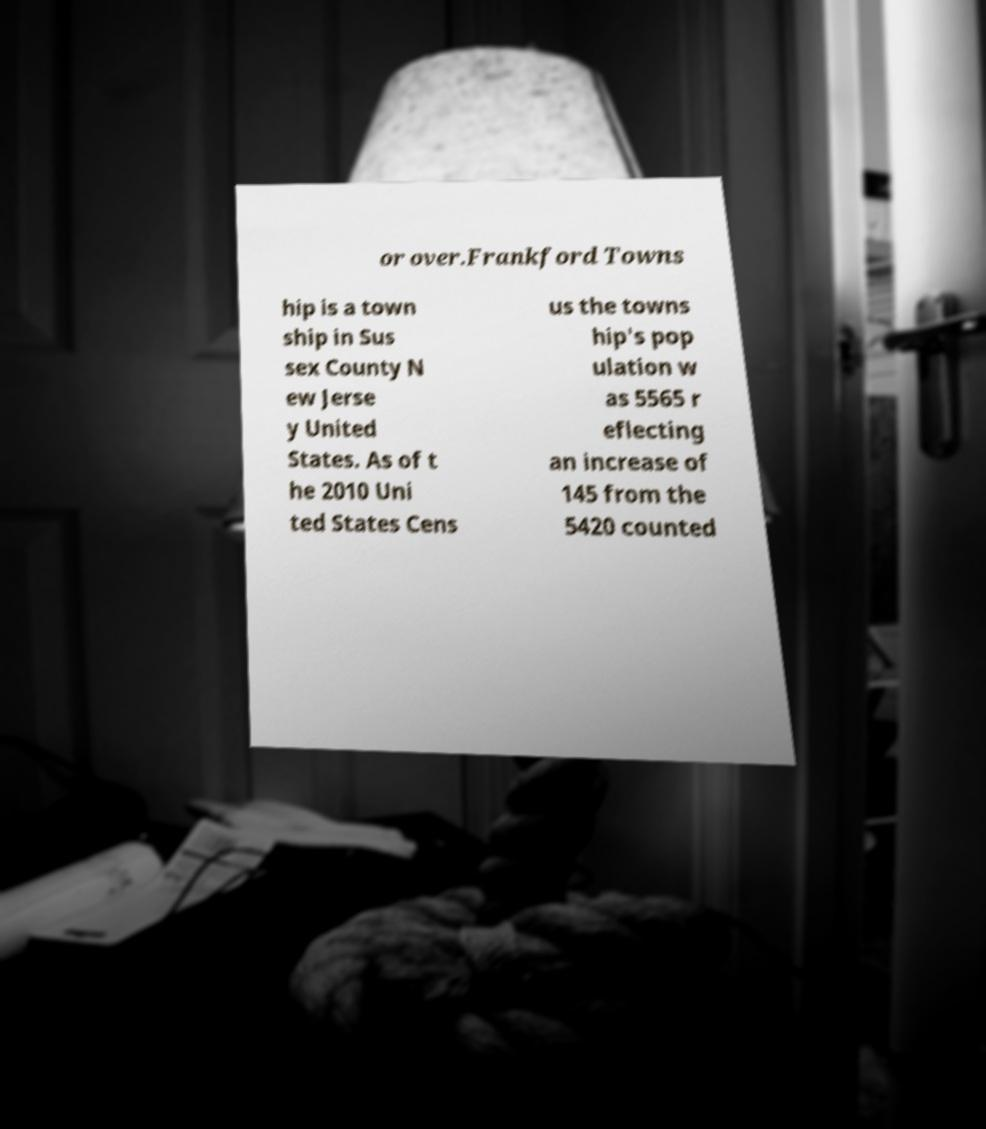For documentation purposes, I need the text within this image transcribed. Could you provide that? or over.Frankford Towns hip is a town ship in Sus sex County N ew Jerse y United States. As of t he 2010 Uni ted States Cens us the towns hip's pop ulation w as 5565 r eflecting an increase of 145 from the 5420 counted 